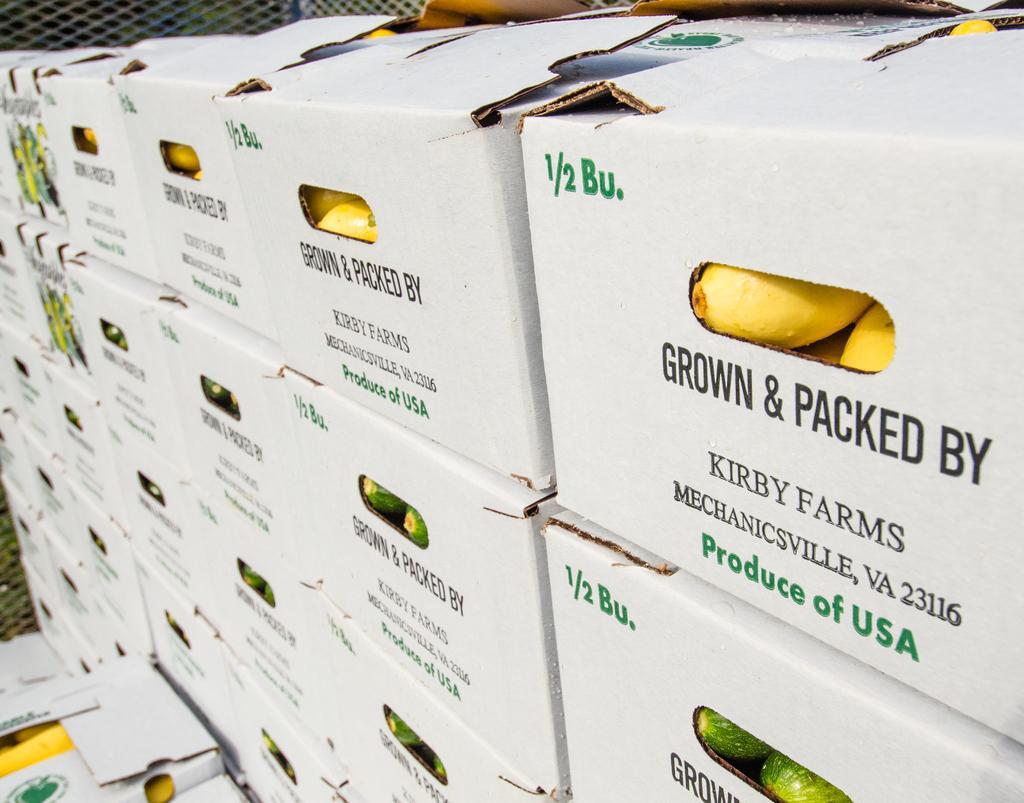Describe this image in one or two sentences. In this image, we can see boxes and in the background, there is a mesh. 